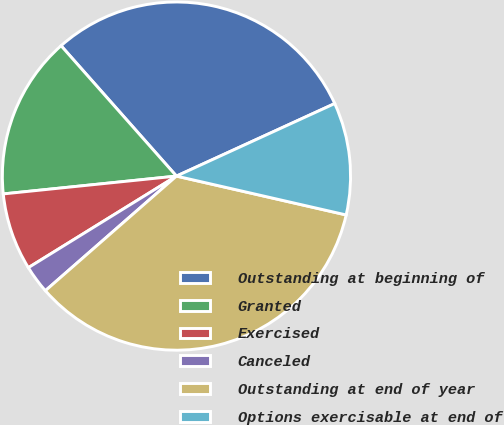<chart> <loc_0><loc_0><loc_500><loc_500><pie_chart><fcel>Outstanding at beginning of<fcel>Granted<fcel>Exercised<fcel>Canceled<fcel>Outstanding at end of year<fcel>Options exercisable at end of<nl><fcel>29.69%<fcel>15.1%<fcel>7.18%<fcel>2.62%<fcel>34.98%<fcel>10.42%<nl></chart> 